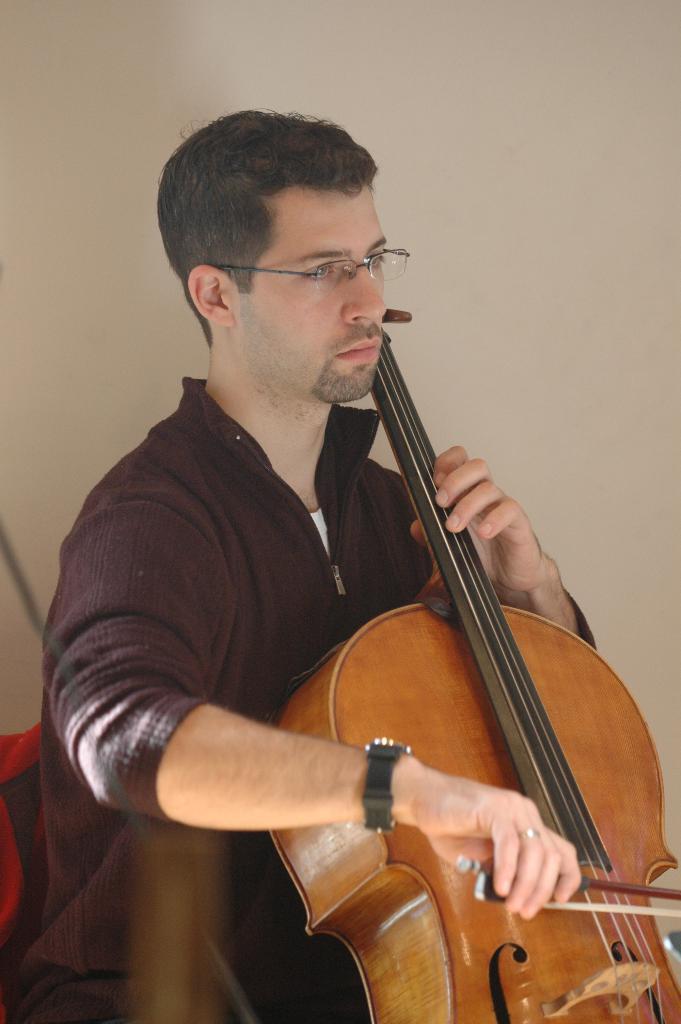In one or two sentences, can you explain what this image depicts? In this image in the center there is one person who is holding a violin and playing, and in the background there is a wall and some other objects. 